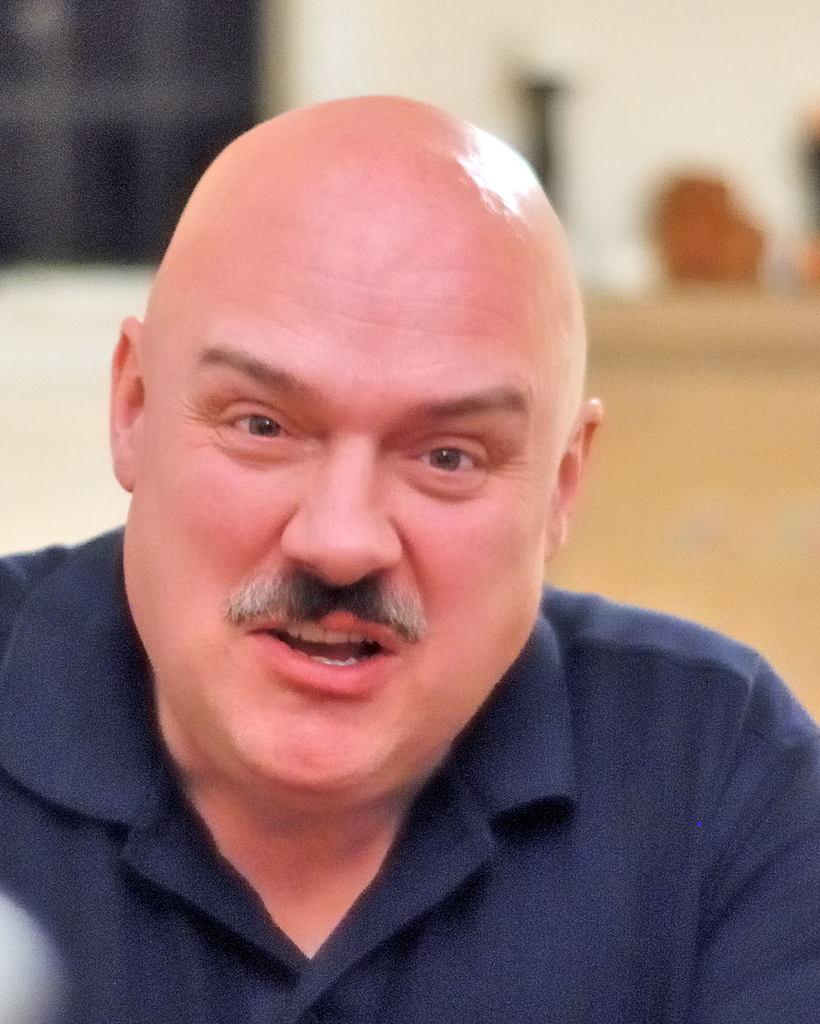What is the appearance of the person's hair in the image? The person in the image is bald. What color is the shirt the person is wearing? The person is wearing a blue shirt. Can you describe the background of the image? The background of the image is blurred. What type of coastline can be seen in the background of the image? There is no coastline visible in the image; the background is blurred. How is the maid dressed in the image? There is no maid present in the image. 